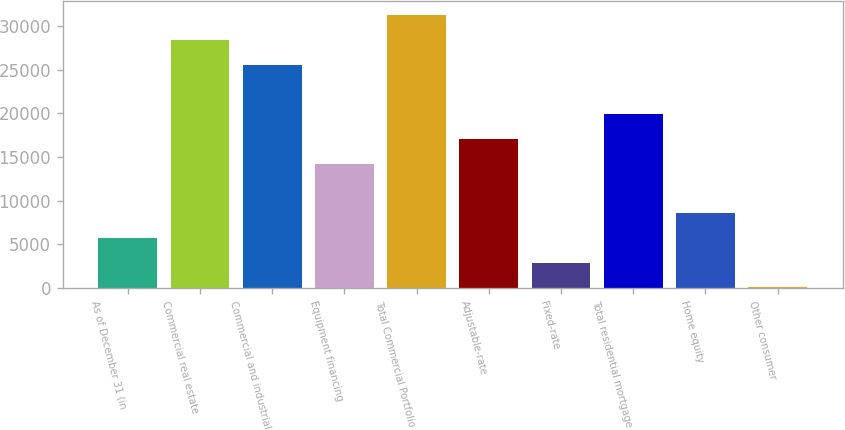Convert chart. <chart><loc_0><loc_0><loc_500><loc_500><bar_chart><fcel>As of December 31 (in<fcel>Commercial real estate<fcel>Commercial and industrial<fcel>Equipment financing<fcel>Total Commercial Portfolio<fcel>Adjustable-rate<fcel>Fixed-rate<fcel>Total residential mortgage<fcel>Home equity<fcel>Other consumer<nl><fcel>5721.7<fcel>28410.9<fcel>25574.8<fcel>14230.1<fcel>31247<fcel>17066.3<fcel>2885.55<fcel>19902.5<fcel>8557.85<fcel>49.4<nl></chart> 